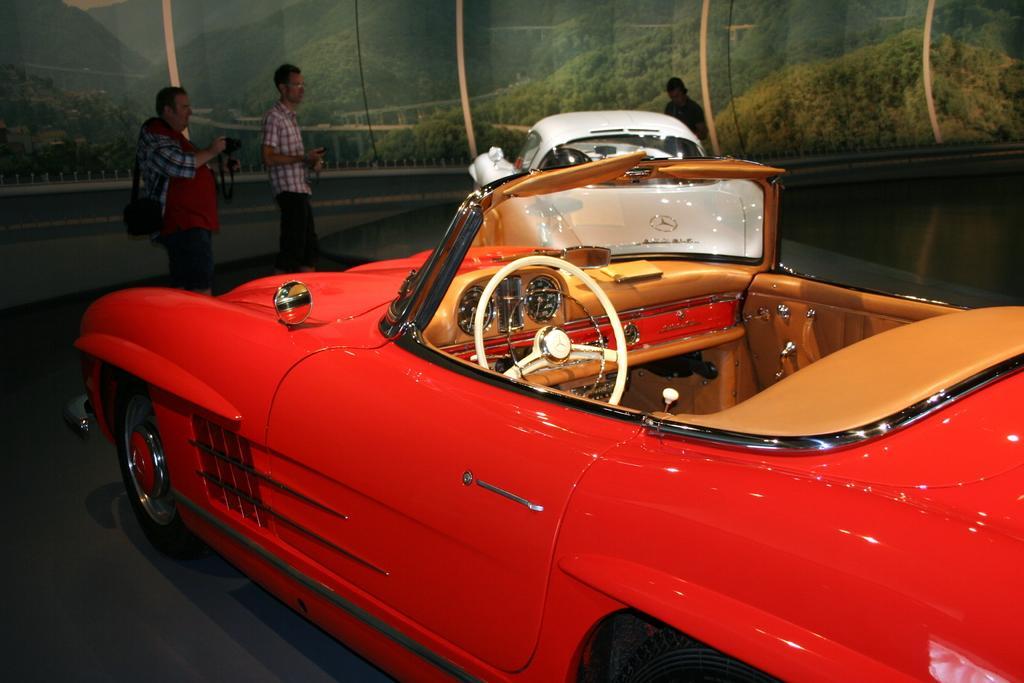How would you summarize this image in a sentence or two? In this picture we can see two cars in the front, there are three persons standing in the middle, a man on the left side is holding a camera, in the background it looks like a cloth, there is picture of scenery on the cloth. 